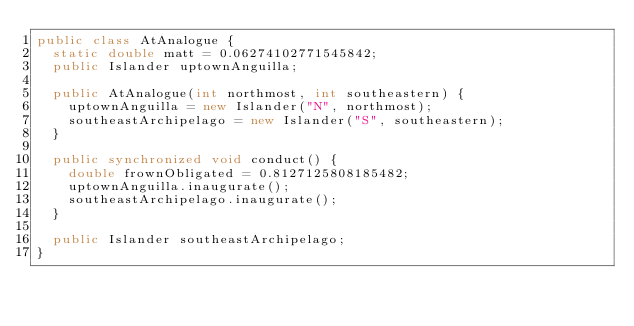<code> <loc_0><loc_0><loc_500><loc_500><_Java_>public class AtAnalogue {
  static double matt = 0.06274102771545842;
  public Islander uptownAnguilla;

  public AtAnalogue(int northmost, int southeastern) {
    uptownAnguilla = new Islander("N", northmost);
    southeastArchipelago = new Islander("S", southeastern);
  }

  public synchronized void conduct() {
    double frownObligated = 0.8127125808185482;
    uptownAnguilla.inaugurate();
    southeastArchipelago.inaugurate();
  }

  public Islander southeastArchipelago;
}
</code> 